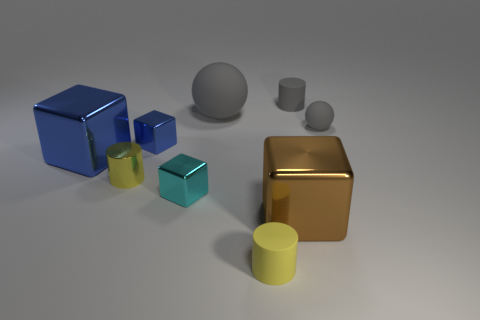Subtract all large blue shiny blocks. How many blocks are left? 3 Subtract all brown cubes. How many cubes are left? 3 Subtract all balls. How many objects are left? 7 Subtract all cyan spheres. How many yellow cylinders are left? 2 Add 8 large shiny balls. How many large shiny balls exist? 8 Subtract 0 green cubes. How many objects are left? 9 Subtract 2 cylinders. How many cylinders are left? 1 Subtract all green cylinders. Subtract all blue blocks. How many cylinders are left? 3 Subtract all small metal things. Subtract all yellow matte cylinders. How many objects are left? 5 Add 2 tiny spheres. How many tiny spheres are left? 3 